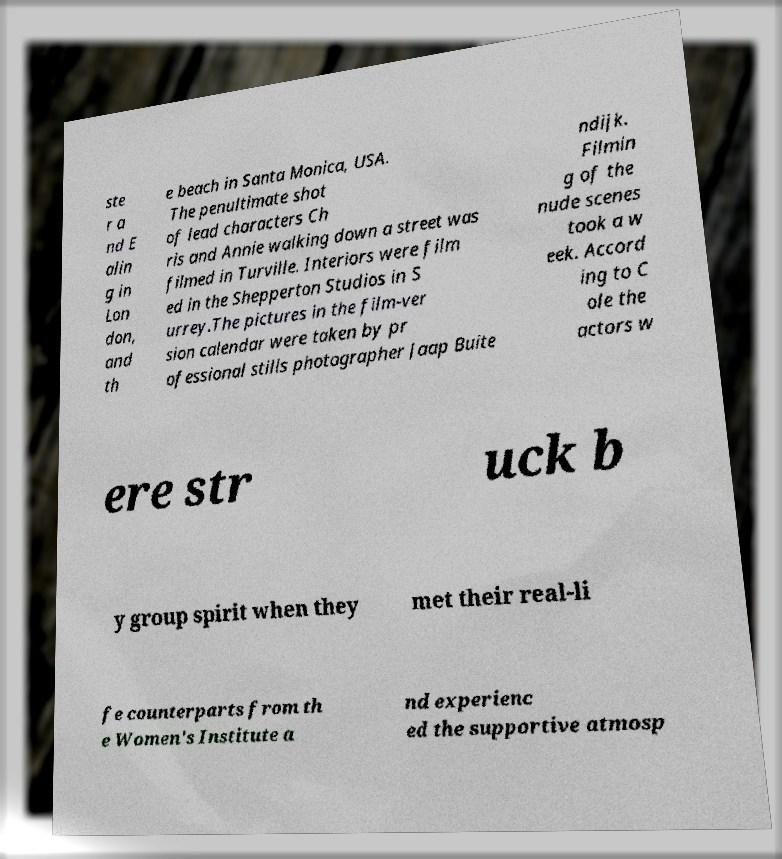What messages or text are displayed in this image? I need them in a readable, typed format. ste r a nd E alin g in Lon don, and th e beach in Santa Monica, USA. The penultimate shot of lead characters Ch ris and Annie walking down a street was filmed in Turville. Interiors were film ed in the Shepperton Studios in S urrey.The pictures in the film-ver sion calendar were taken by pr ofessional stills photographer Jaap Buite ndijk. Filmin g of the nude scenes took a w eek. Accord ing to C ole the actors w ere str uck b y group spirit when they met their real-li fe counterparts from th e Women's Institute a nd experienc ed the supportive atmosp 